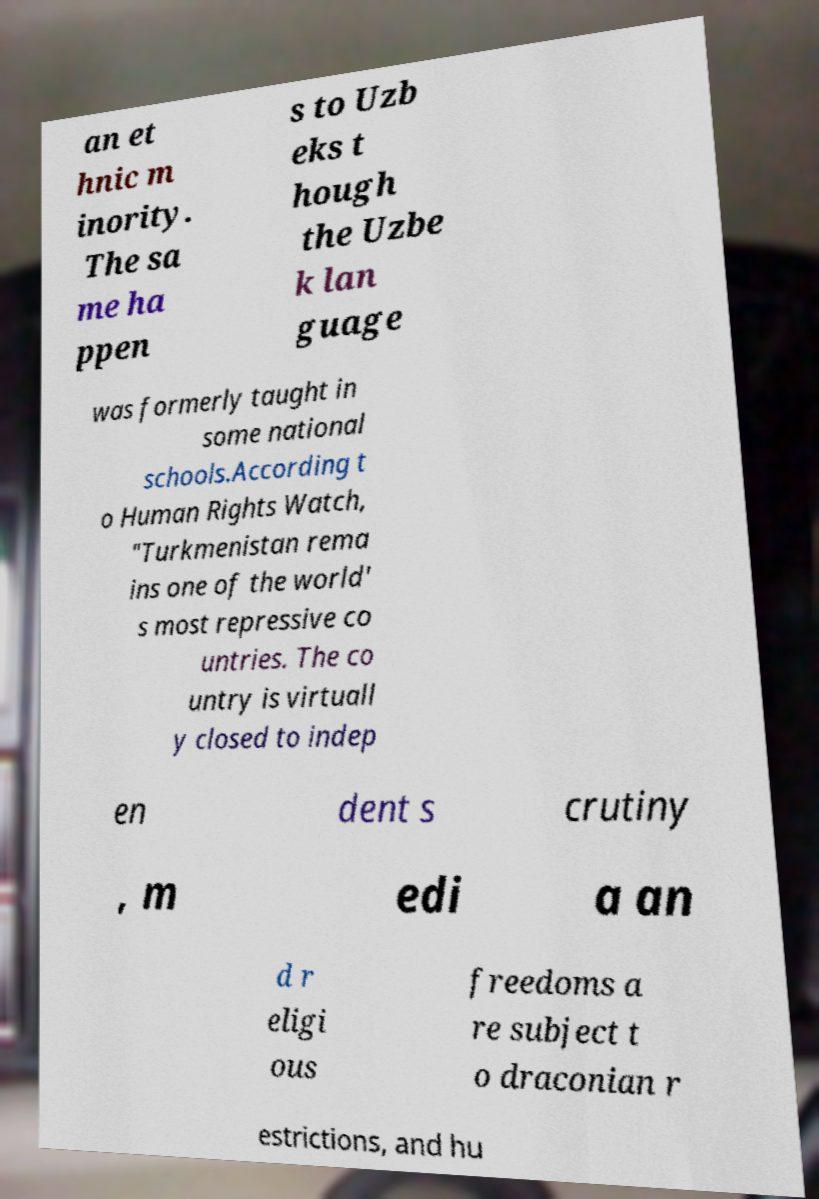Could you extract and type out the text from this image? an et hnic m inority. The sa me ha ppen s to Uzb eks t hough the Uzbe k lan guage was formerly taught in some national schools.According t o Human Rights Watch, "Turkmenistan rema ins one of the world' s most repressive co untries. The co untry is virtuall y closed to indep en dent s crutiny , m edi a an d r eligi ous freedoms a re subject t o draconian r estrictions, and hu 